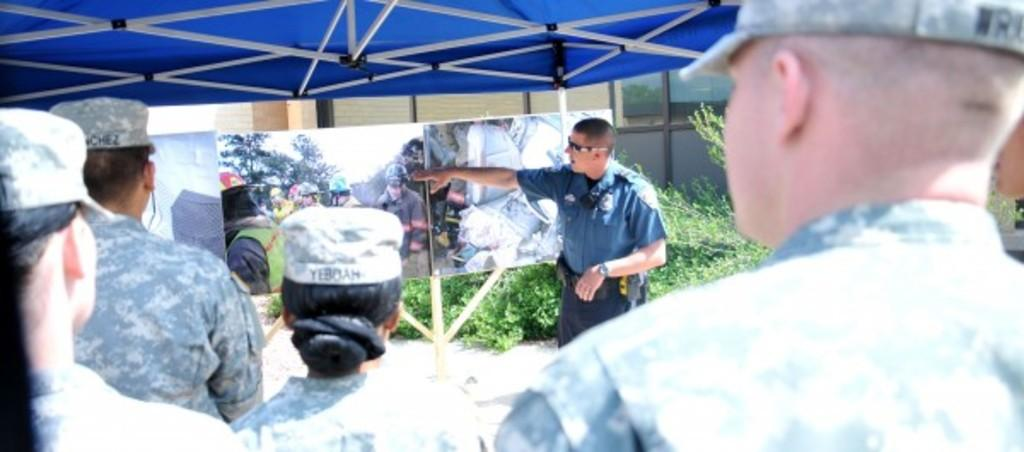What type of clothing are the people wearing in the image? The people in the image are wearing army uniforms. What else can be seen in the image besides the people? There are pictures, a blue object, and rods visible in the image. What is present in the background of the image? There are plants in the background of the image. What type of sound can be heard coming from the throat of the person in the image? There is no indication of any sound or throat activity in the image, as it only shows people wearing army uniforms, pictures, a blue object, rods, and plants in the background. 